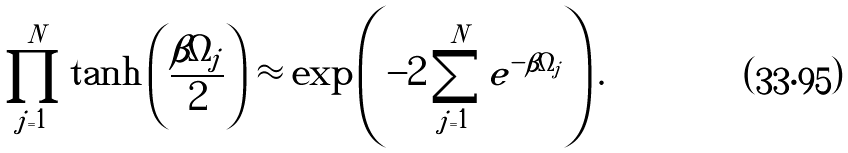<formula> <loc_0><loc_0><loc_500><loc_500>\prod _ { j = 1 } ^ { N } \tanh \left ( \frac { \beta \Omega _ { j } } { 2 } \right ) \approx \exp \left ( - 2 \sum _ { j = 1 } ^ { N } e ^ { - \beta \Omega _ { j } } \right ) .</formula> 